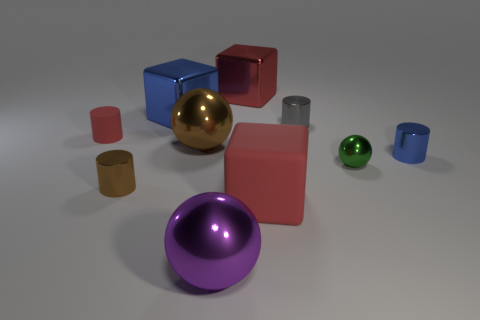How many brown objects are either big shiny balls or spheres?
Offer a terse response. 1. Is the number of big metal objects that are behind the large red rubber thing greater than the number of tiny green metal objects?
Your response must be concise. Yes. Does the red metallic cube have the same size as the brown metallic ball?
Provide a succinct answer. Yes. What is the color of the tiny sphere that is the same material as the gray cylinder?
Your response must be concise. Green. There is a matte thing that is the same color as the rubber cylinder; what is its shape?
Your answer should be compact. Cube. Are there an equal number of tiny red rubber cylinders that are to the right of the red rubber cylinder and large blue metal things in front of the brown ball?
Offer a very short reply. Yes. There is a big red metal thing that is on the left side of the blue object in front of the gray cylinder; what shape is it?
Ensure brevity in your answer.  Cube. There is a large blue thing that is the same shape as the big red matte thing; what is it made of?
Provide a succinct answer. Metal. The matte cube that is the same size as the purple thing is what color?
Your answer should be very brief. Red. Is the number of gray cylinders that are right of the red shiny object the same as the number of cyan metallic cylinders?
Provide a succinct answer. No. 